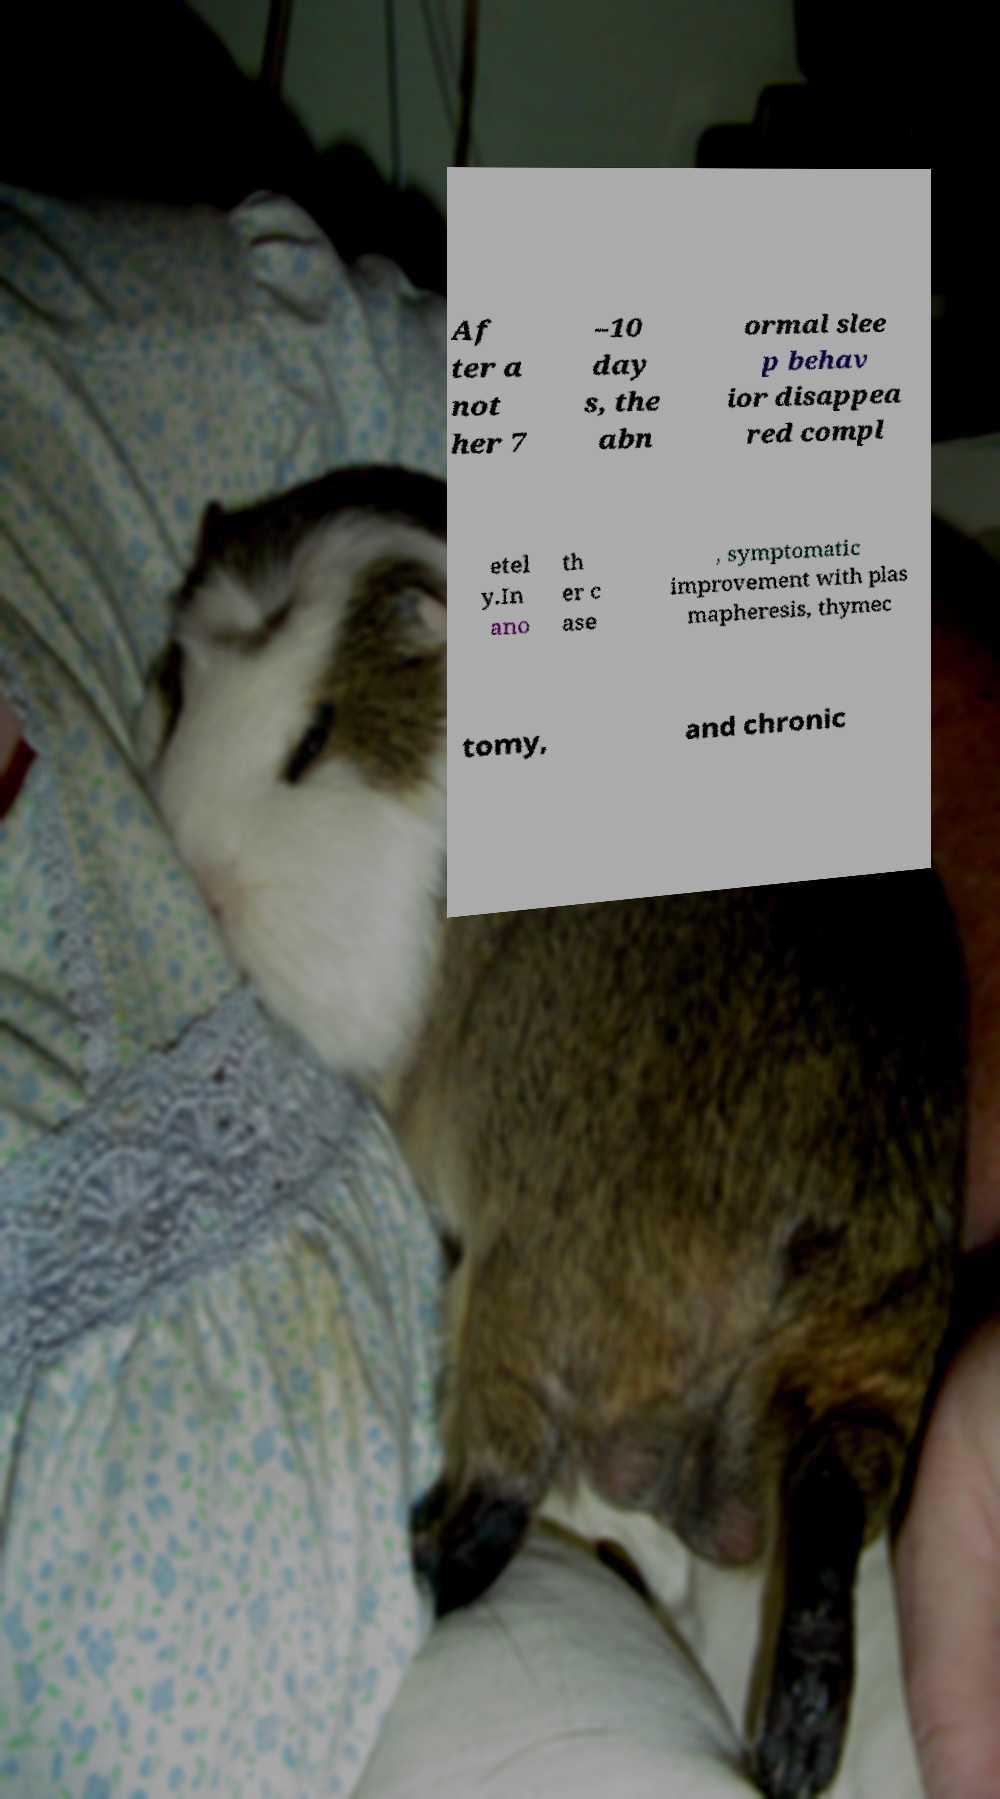What messages or text are displayed in this image? I need them in a readable, typed format. Af ter a not her 7 –10 day s, the abn ormal slee p behav ior disappea red compl etel y.In ano th er c ase , symptomatic improvement with plas mapheresis, thymec tomy, and chronic 